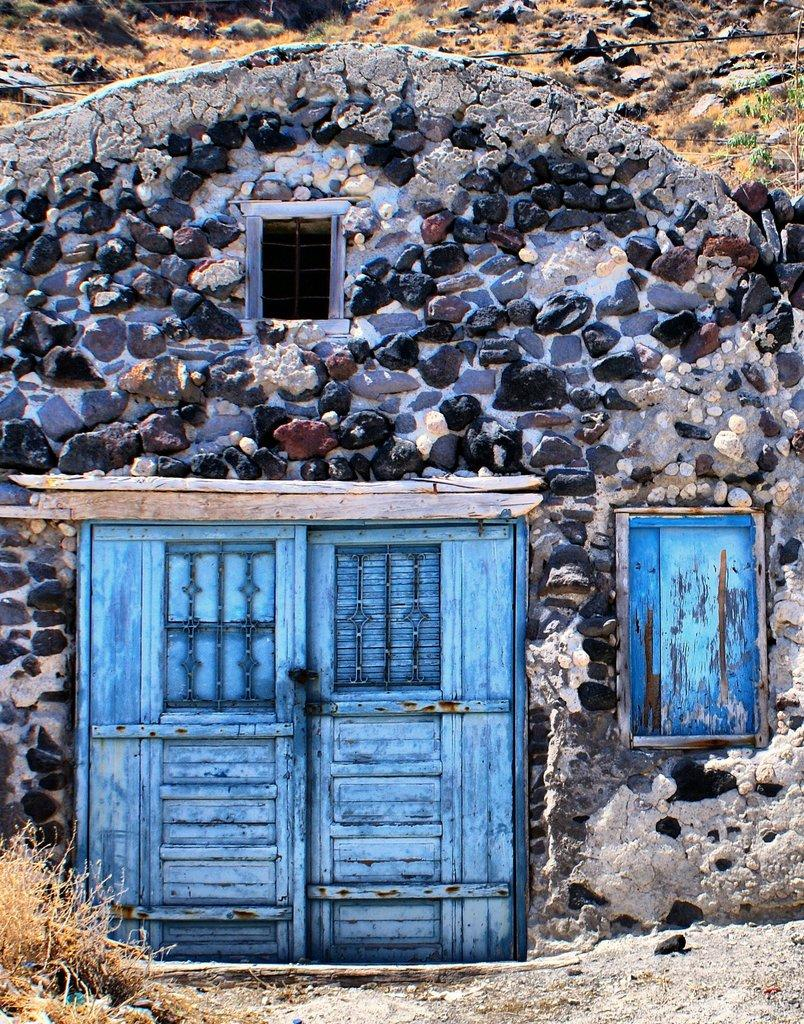What type of structure is visible in the image? There is a house in the image. What features can be seen on the house? The house has doors and a window. What can be seen in the background of the image? There are rocks in the background of the image. What type of vegetation is present on the ground in the image? There is grass on the ground in the image. What type of quiver is hanging on the wall inside the house? There is no quiver present in the image; it only shows a house with doors, a window, rocks in the background, and grass on the ground. 